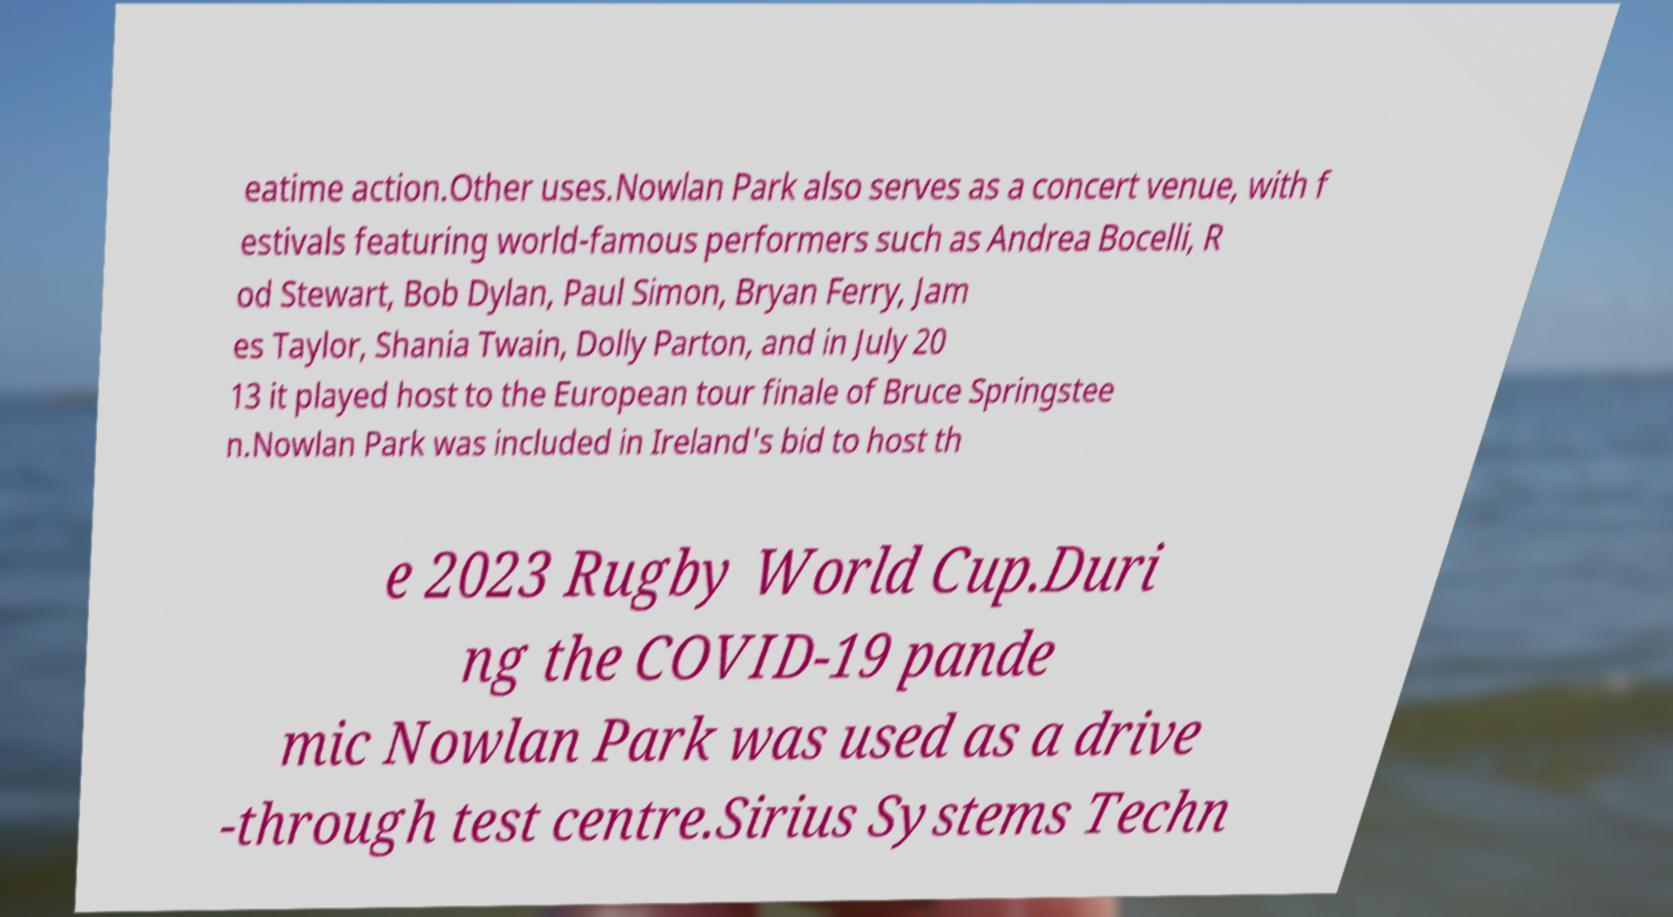Please read and relay the text visible in this image. What does it say? eatime action.Other uses.Nowlan Park also serves as a concert venue, with f estivals featuring world-famous performers such as Andrea Bocelli, R od Stewart, Bob Dylan, Paul Simon, Bryan Ferry, Jam es Taylor, Shania Twain, Dolly Parton, and in July 20 13 it played host to the European tour finale of Bruce Springstee n.Nowlan Park was included in Ireland's bid to host th e 2023 Rugby World Cup.Duri ng the COVID-19 pande mic Nowlan Park was used as a drive -through test centre.Sirius Systems Techn 